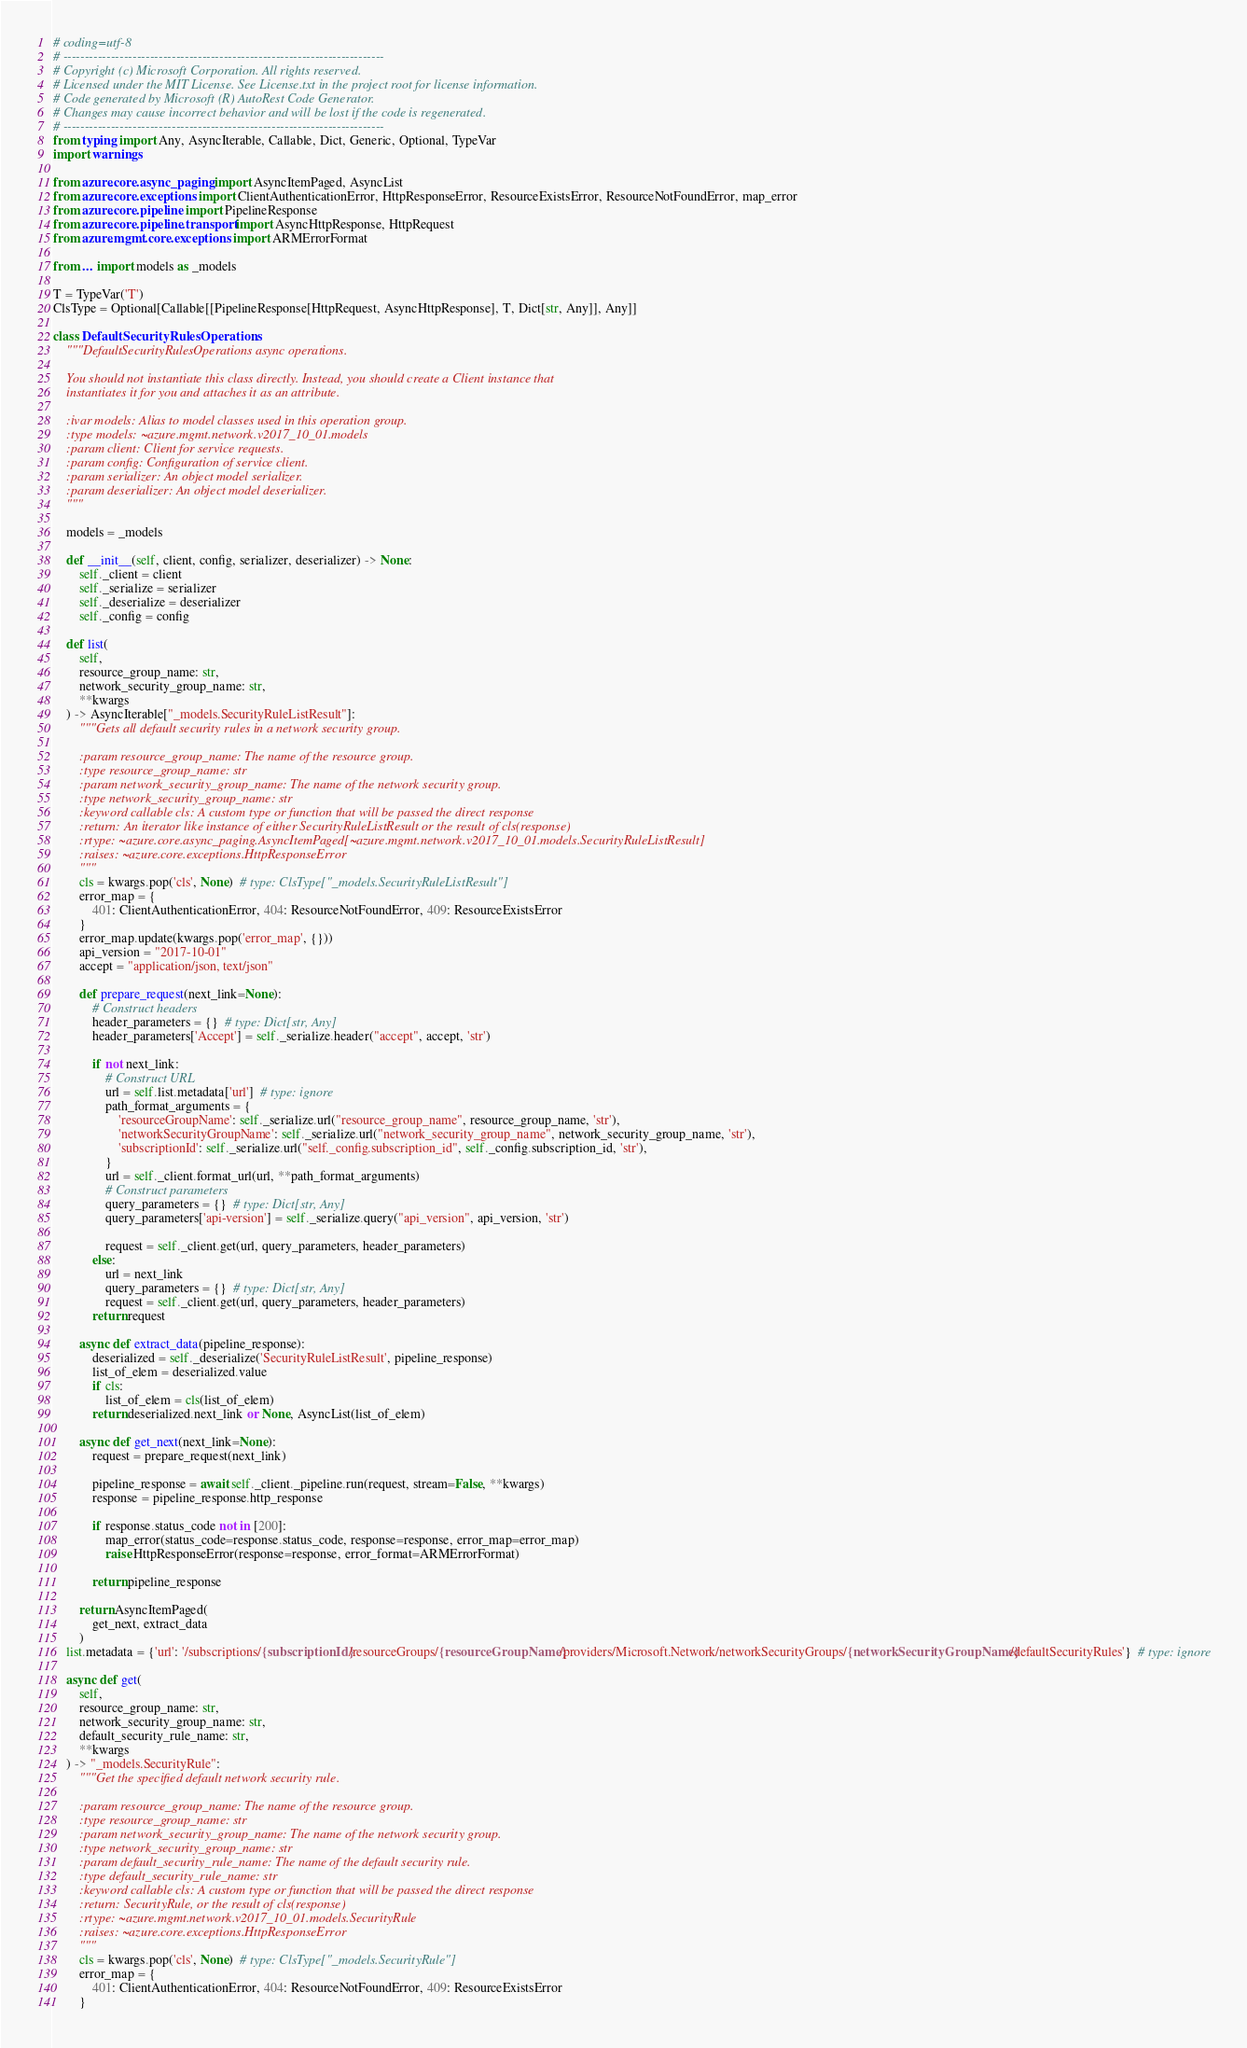Convert code to text. <code><loc_0><loc_0><loc_500><loc_500><_Python_># coding=utf-8
# --------------------------------------------------------------------------
# Copyright (c) Microsoft Corporation. All rights reserved.
# Licensed under the MIT License. See License.txt in the project root for license information.
# Code generated by Microsoft (R) AutoRest Code Generator.
# Changes may cause incorrect behavior and will be lost if the code is regenerated.
# --------------------------------------------------------------------------
from typing import Any, AsyncIterable, Callable, Dict, Generic, Optional, TypeVar
import warnings

from azure.core.async_paging import AsyncItemPaged, AsyncList
from azure.core.exceptions import ClientAuthenticationError, HttpResponseError, ResourceExistsError, ResourceNotFoundError, map_error
from azure.core.pipeline import PipelineResponse
from azure.core.pipeline.transport import AsyncHttpResponse, HttpRequest
from azure.mgmt.core.exceptions import ARMErrorFormat

from ... import models as _models

T = TypeVar('T')
ClsType = Optional[Callable[[PipelineResponse[HttpRequest, AsyncHttpResponse], T, Dict[str, Any]], Any]]

class DefaultSecurityRulesOperations:
    """DefaultSecurityRulesOperations async operations.

    You should not instantiate this class directly. Instead, you should create a Client instance that
    instantiates it for you and attaches it as an attribute.

    :ivar models: Alias to model classes used in this operation group.
    :type models: ~azure.mgmt.network.v2017_10_01.models
    :param client: Client for service requests.
    :param config: Configuration of service client.
    :param serializer: An object model serializer.
    :param deserializer: An object model deserializer.
    """

    models = _models

    def __init__(self, client, config, serializer, deserializer) -> None:
        self._client = client
        self._serialize = serializer
        self._deserialize = deserializer
        self._config = config

    def list(
        self,
        resource_group_name: str,
        network_security_group_name: str,
        **kwargs
    ) -> AsyncIterable["_models.SecurityRuleListResult"]:
        """Gets all default security rules in a network security group.

        :param resource_group_name: The name of the resource group.
        :type resource_group_name: str
        :param network_security_group_name: The name of the network security group.
        :type network_security_group_name: str
        :keyword callable cls: A custom type or function that will be passed the direct response
        :return: An iterator like instance of either SecurityRuleListResult or the result of cls(response)
        :rtype: ~azure.core.async_paging.AsyncItemPaged[~azure.mgmt.network.v2017_10_01.models.SecurityRuleListResult]
        :raises: ~azure.core.exceptions.HttpResponseError
        """
        cls = kwargs.pop('cls', None)  # type: ClsType["_models.SecurityRuleListResult"]
        error_map = {
            401: ClientAuthenticationError, 404: ResourceNotFoundError, 409: ResourceExistsError
        }
        error_map.update(kwargs.pop('error_map', {}))
        api_version = "2017-10-01"
        accept = "application/json, text/json"

        def prepare_request(next_link=None):
            # Construct headers
            header_parameters = {}  # type: Dict[str, Any]
            header_parameters['Accept'] = self._serialize.header("accept", accept, 'str')

            if not next_link:
                # Construct URL
                url = self.list.metadata['url']  # type: ignore
                path_format_arguments = {
                    'resourceGroupName': self._serialize.url("resource_group_name", resource_group_name, 'str'),
                    'networkSecurityGroupName': self._serialize.url("network_security_group_name", network_security_group_name, 'str'),
                    'subscriptionId': self._serialize.url("self._config.subscription_id", self._config.subscription_id, 'str'),
                }
                url = self._client.format_url(url, **path_format_arguments)
                # Construct parameters
                query_parameters = {}  # type: Dict[str, Any]
                query_parameters['api-version'] = self._serialize.query("api_version", api_version, 'str')

                request = self._client.get(url, query_parameters, header_parameters)
            else:
                url = next_link
                query_parameters = {}  # type: Dict[str, Any]
                request = self._client.get(url, query_parameters, header_parameters)
            return request

        async def extract_data(pipeline_response):
            deserialized = self._deserialize('SecurityRuleListResult', pipeline_response)
            list_of_elem = deserialized.value
            if cls:
                list_of_elem = cls(list_of_elem)
            return deserialized.next_link or None, AsyncList(list_of_elem)

        async def get_next(next_link=None):
            request = prepare_request(next_link)

            pipeline_response = await self._client._pipeline.run(request, stream=False, **kwargs)
            response = pipeline_response.http_response

            if response.status_code not in [200]:
                map_error(status_code=response.status_code, response=response, error_map=error_map)
                raise HttpResponseError(response=response, error_format=ARMErrorFormat)

            return pipeline_response

        return AsyncItemPaged(
            get_next, extract_data
        )
    list.metadata = {'url': '/subscriptions/{subscriptionId}/resourceGroups/{resourceGroupName}/providers/Microsoft.Network/networkSecurityGroups/{networkSecurityGroupName}/defaultSecurityRules'}  # type: ignore

    async def get(
        self,
        resource_group_name: str,
        network_security_group_name: str,
        default_security_rule_name: str,
        **kwargs
    ) -> "_models.SecurityRule":
        """Get the specified default network security rule.

        :param resource_group_name: The name of the resource group.
        :type resource_group_name: str
        :param network_security_group_name: The name of the network security group.
        :type network_security_group_name: str
        :param default_security_rule_name: The name of the default security rule.
        :type default_security_rule_name: str
        :keyword callable cls: A custom type or function that will be passed the direct response
        :return: SecurityRule, or the result of cls(response)
        :rtype: ~azure.mgmt.network.v2017_10_01.models.SecurityRule
        :raises: ~azure.core.exceptions.HttpResponseError
        """
        cls = kwargs.pop('cls', None)  # type: ClsType["_models.SecurityRule"]
        error_map = {
            401: ClientAuthenticationError, 404: ResourceNotFoundError, 409: ResourceExistsError
        }</code> 